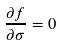Convert formula to latex. <formula><loc_0><loc_0><loc_500><loc_500>\frac { \partial f } { \partial \sigma } = 0</formula> 